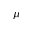Convert formula to latex. <formula><loc_0><loc_0><loc_500><loc_500>\mu</formula> 